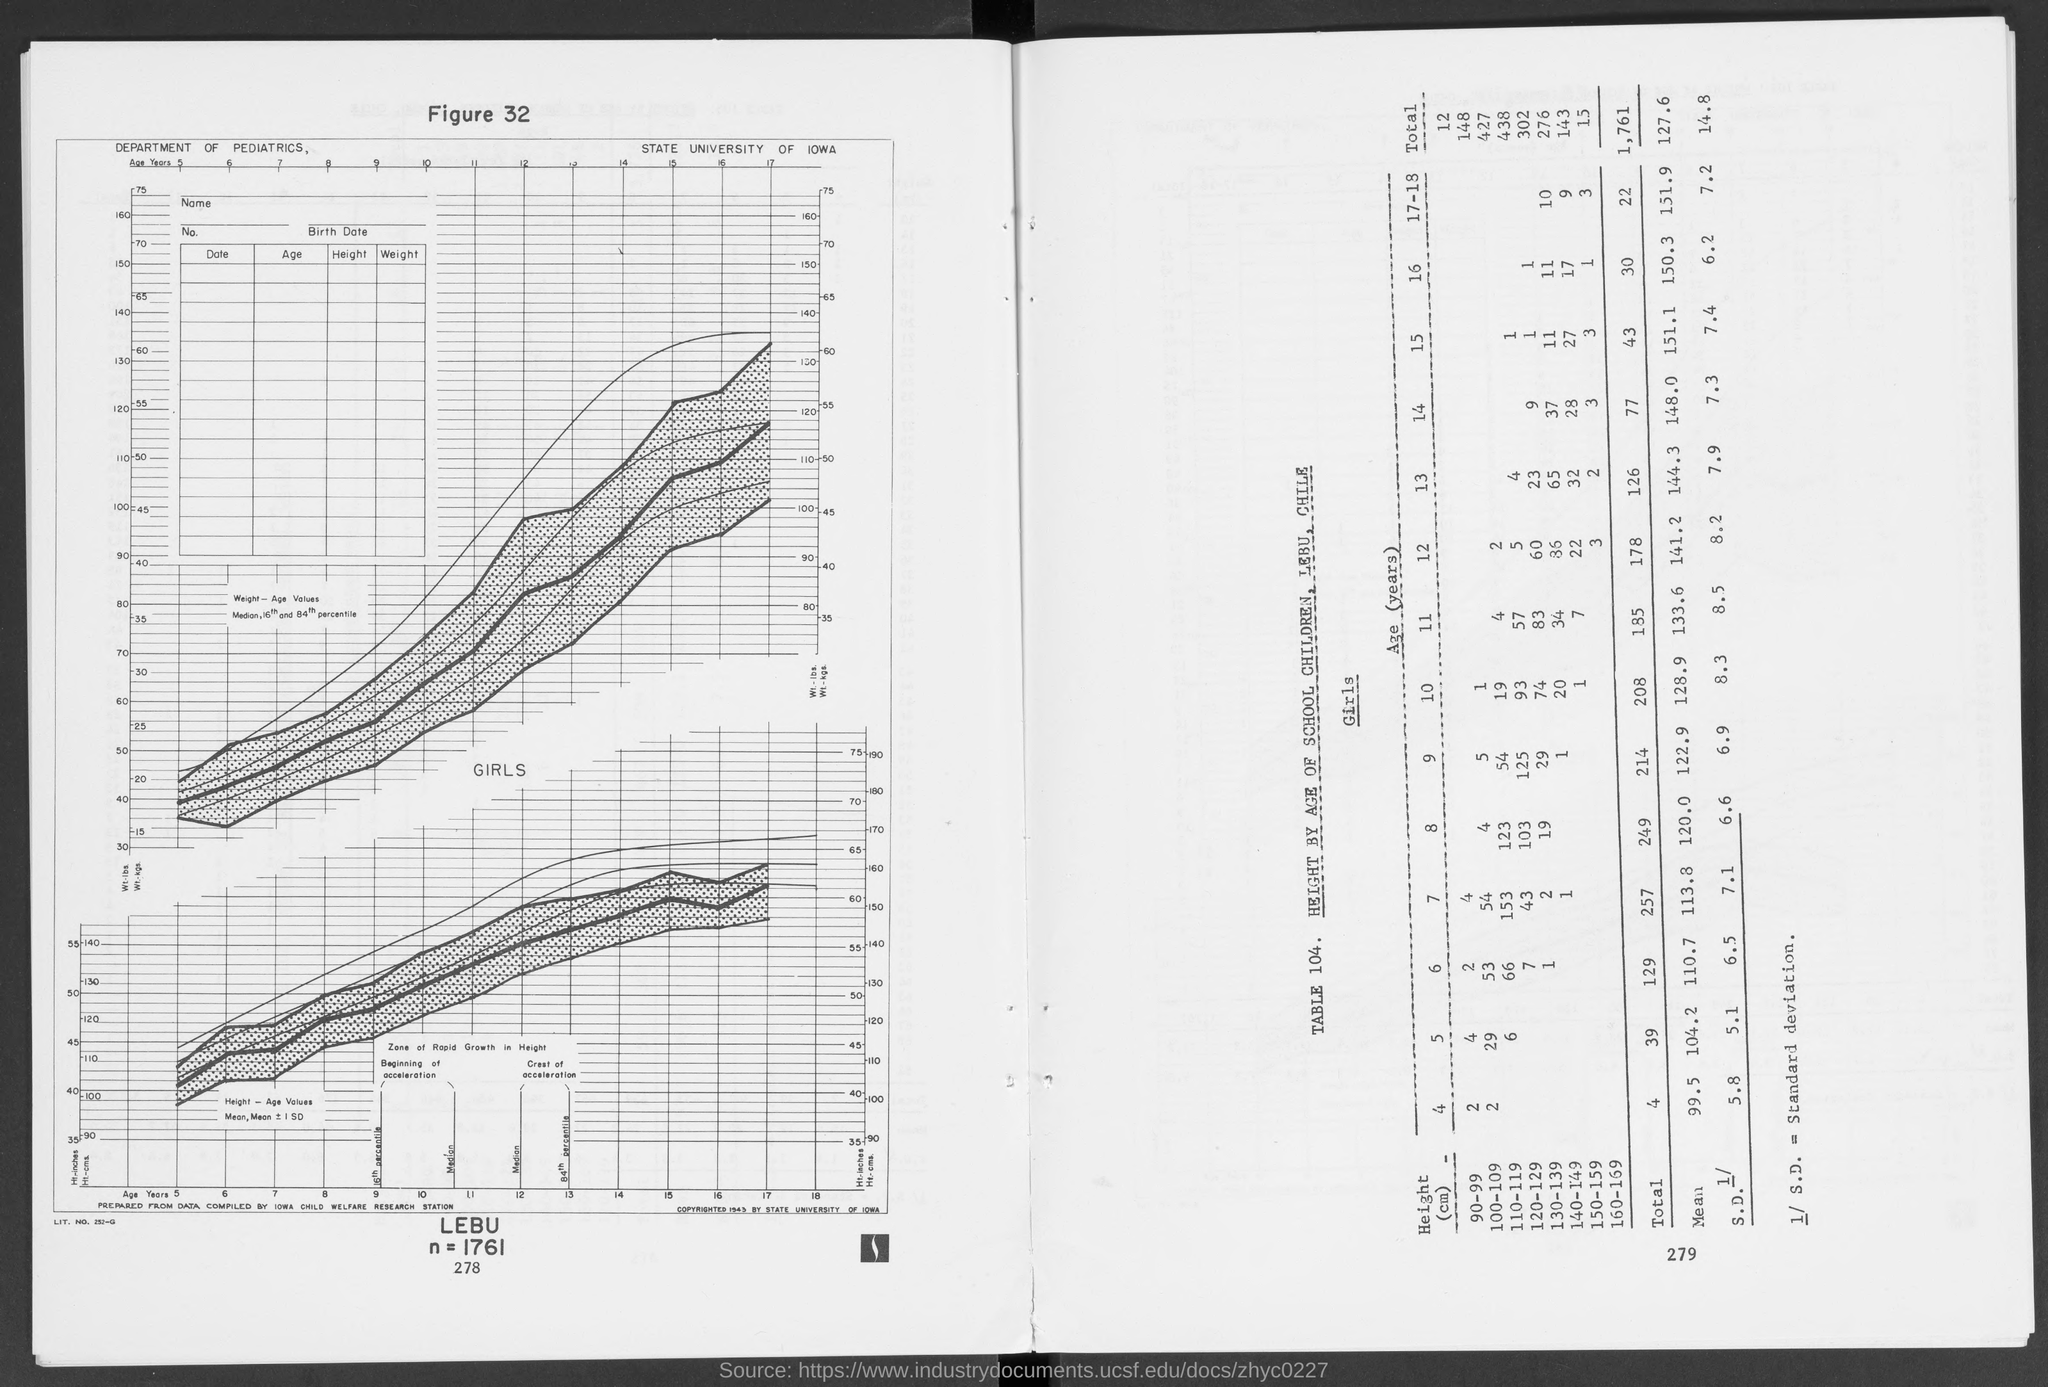Outline some significant characteristics in this image. The title of Table 104 is 'Height by Age of School Children in Lebu and Chile.' 